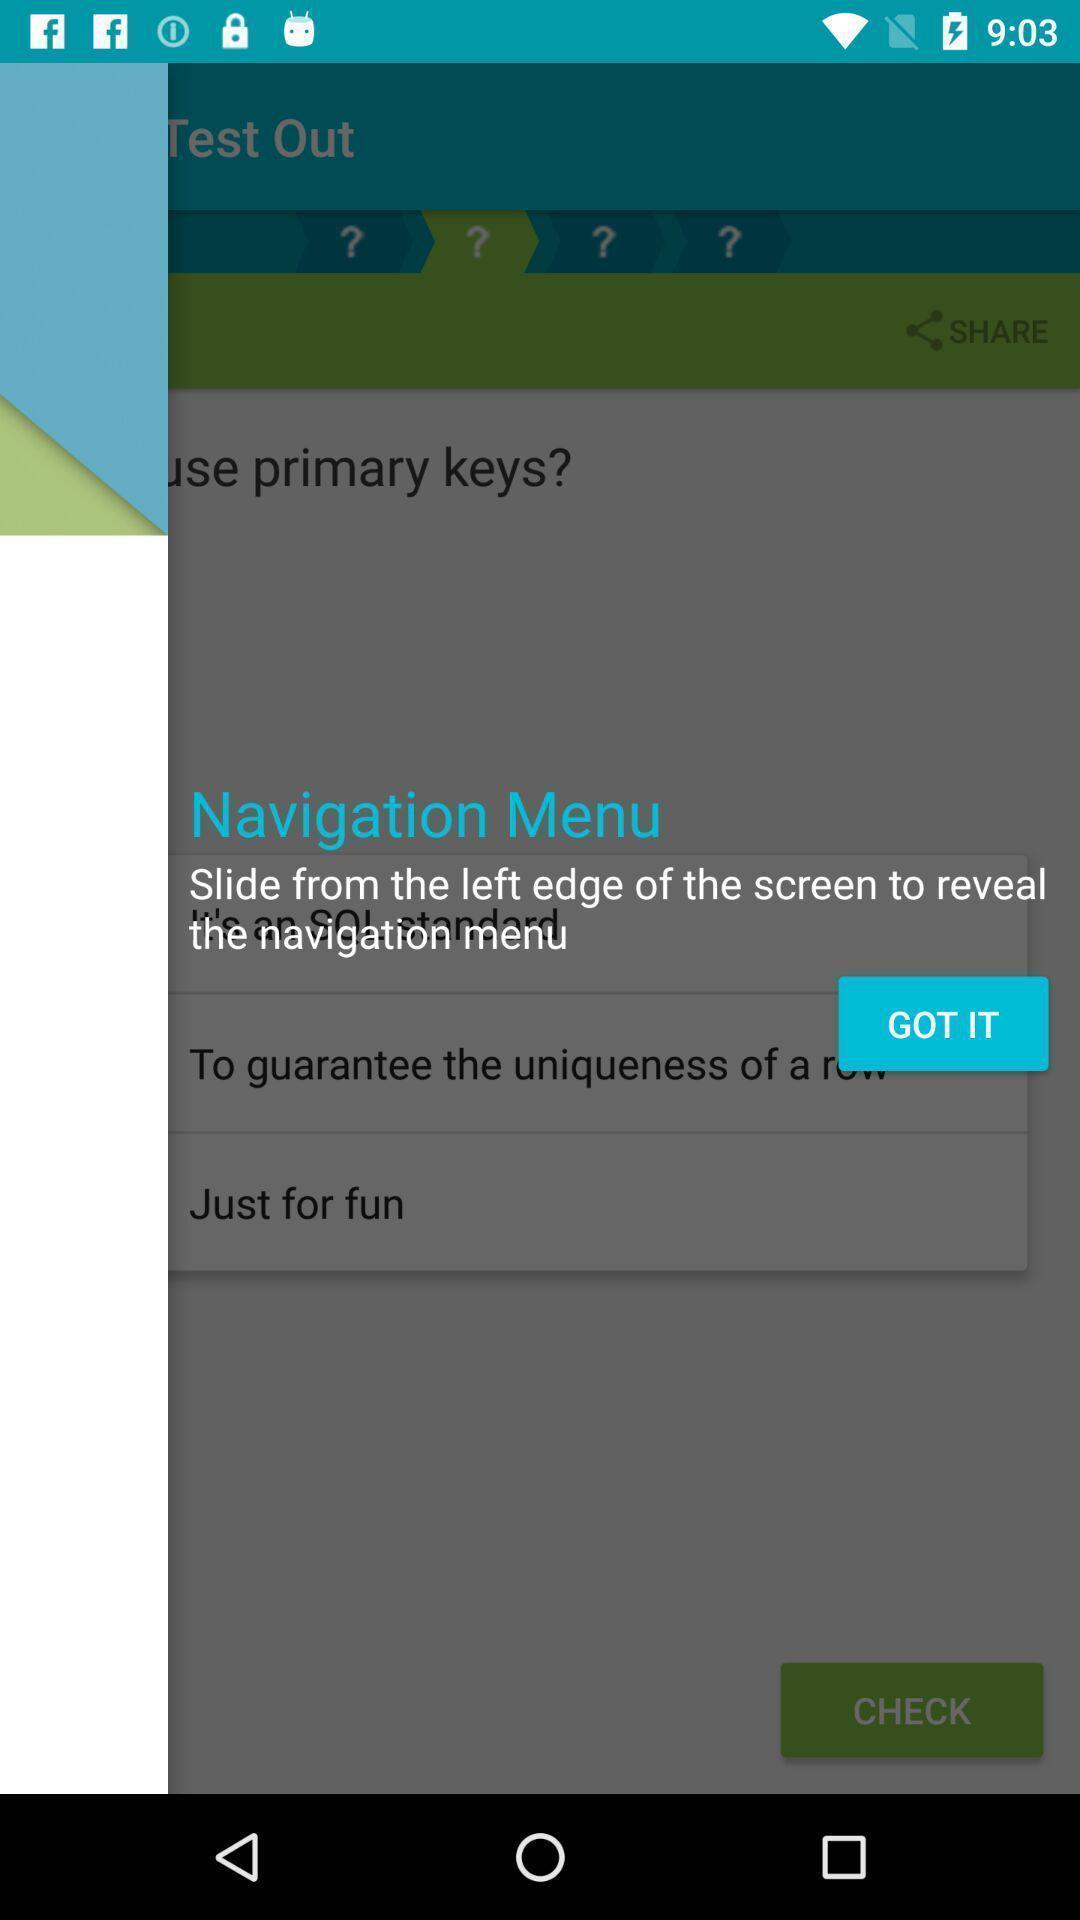Please provide a description for this image. Pop-up screen displaying with the information about the feature. 